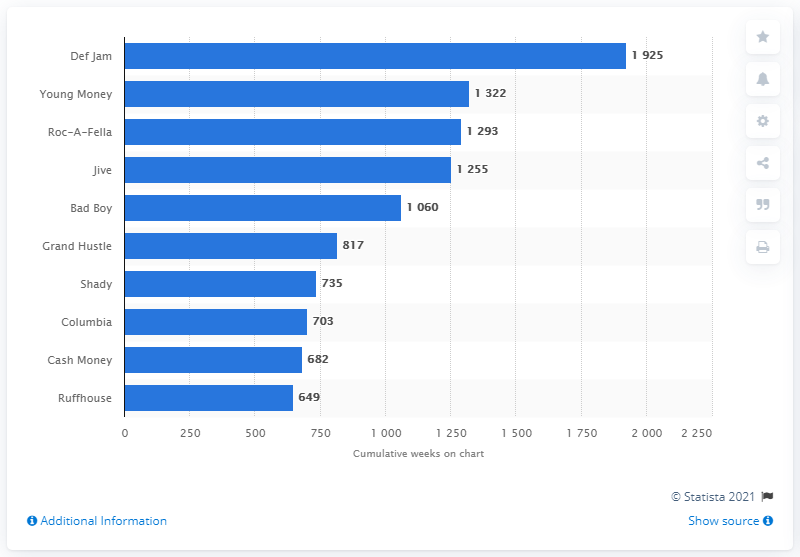Give some essential details in this illustration. The sum of Cash Money and Ruffhouse is 1331. The value for Jive is 1,255. 